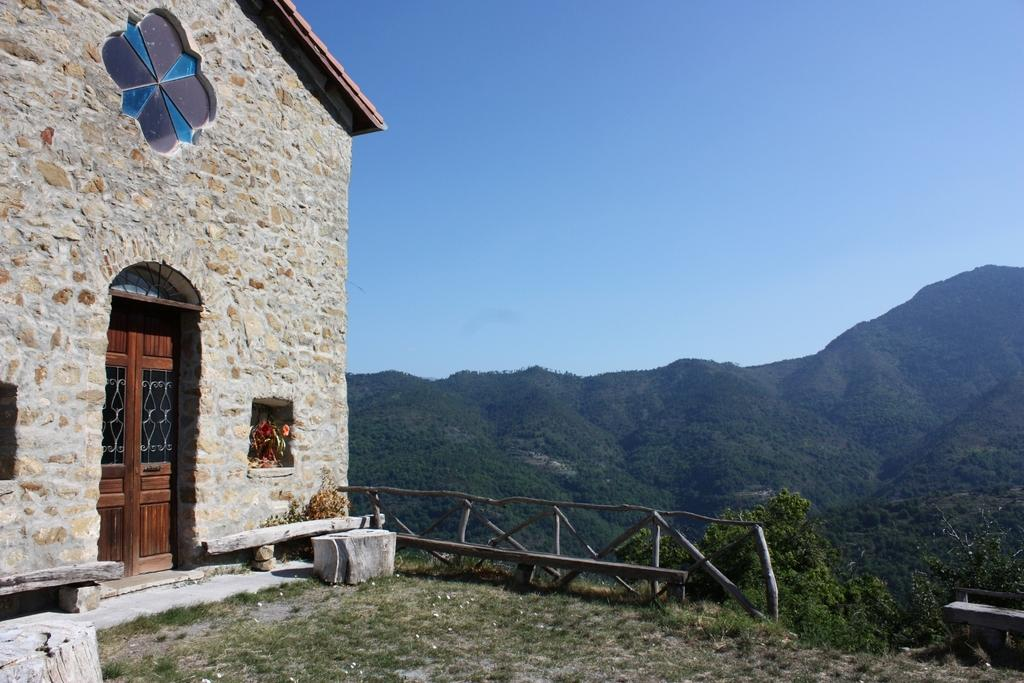What type of structure is located on the left side of the image? There is a house with doors on the left side of the image. What type of natural feature can be seen on the right side of the image? There are hills on the right side of the image. What is visible at the top of the image? The sky is visible at the top of the image. What is the purpose of the battle that is taking place in the image? There is no battle present in the image; it features a house and hills. How does the memory of the event relate to the image? There is no event or memory mentioned in the image; it only shows a house, hills, and the sky. 